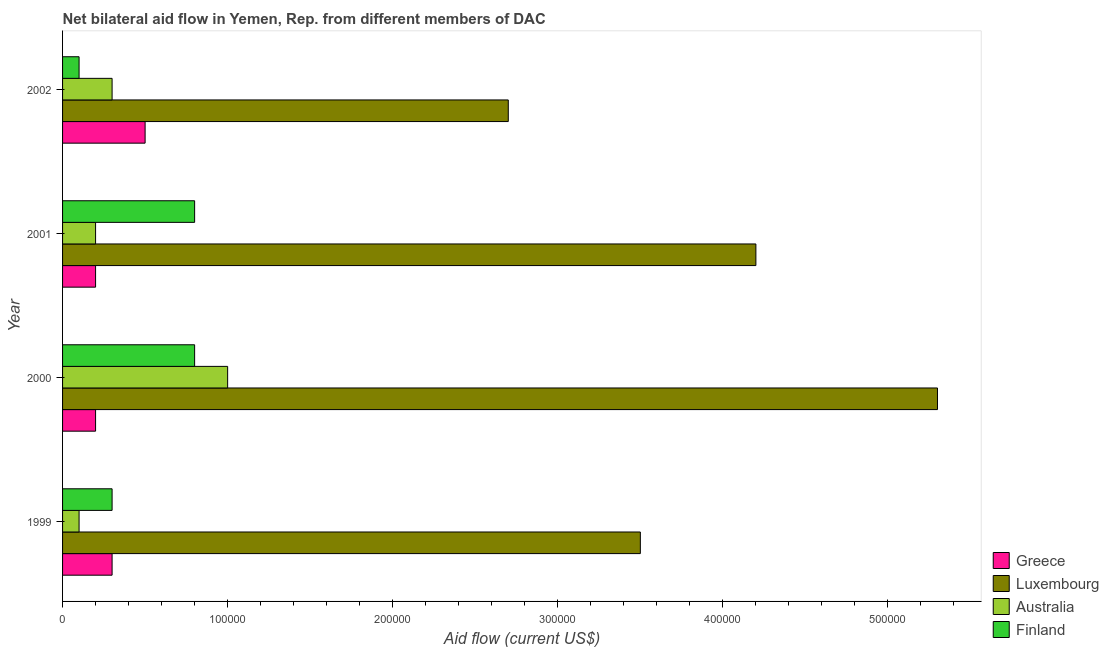How many different coloured bars are there?
Your answer should be very brief. 4. How many groups of bars are there?
Provide a short and direct response. 4. Are the number of bars per tick equal to the number of legend labels?
Provide a short and direct response. Yes. What is the amount of aid given by luxembourg in 2001?
Offer a terse response. 4.20e+05. Across all years, what is the maximum amount of aid given by luxembourg?
Provide a short and direct response. 5.30e+05. Across all years, what is the minimum amount of aid given by luxembourg?
Keep it short and to the point. 2.70e+05. In which year was the amount of aid given by finland maximum?
Offer a terse response. 2000. In which year was the amount of aid given by australia minimum?
Give a very brief answer. 1999. What is the total amount of aid given by luxembourg in the graph?
Give a very brief answer. 1.57e+06. What is the difference between the amount of aid given by greece in 1999 and that in 2001?
Keep it short and to the point. 10000. What is the difference between the amount of aid given by finland in 2000 and the amount of aid given by australia in 1999?
Give a very brief answer. 7.00e+04. What is the average amount of aid given by australia per year?
Provide a succinct answer. 4.00e+04. In the year 2001, what is the difference between the amount of aid given by australia and amount of aid given by greece?
Make the answer very short. 0. What is the ratio of the amount of aid given by luxembourg in 1999 to that in 2000?
Give a very brief answer. 0.66. What is the difference between the highest and the lowest amount of aid given by greece?
Ensure brevity in your answer.  3.00e+04. Is the sum of the amount of aid given by australia in 2000 and 2001 greater than the maximum amount of aid given by finland across all years?
Give a very brief answer. Yes. Is it the case that in every year, the sum of the amount of aid given by luxembourg and amount of aid given by australia is greater than the sum of amount of aid given by finland and amount of aid given by greece?
Provide a succinct answer. Yes. What does the 4th bar from the bottom in 2002 represents?
Provide a short and direct response. Finland. What is the difference between two consecutive major ticks on the X-axis?
Ensure brevity in your answer.  1.00e+05. Are the values on the major ticks of X-axis written in scientific E-notation?
Your answer should be compact. No. Where does the legend appear in the graph?
Offer a very short reply. Bottom right. How are the legend labels stacked?
Provide a short and direct response. Vertical. What is the title of the graph?
Your answer should be compact. Net bilateral aid flow in Yemen, Rep. from different members of DAC. Does "Minerals" appear as one of the legend labels in the graph?
Ensure brevity in your answer.  No. What is the label or title of the X-axis?
Make the answer very short. Aid flow (current US$). What is the Aid flow (current US$) of Greece in 1999?
Make the answer very short. 3.00e+04. What is the Aid flow (current US$) of Luxembourg in 1999?
Your response must be concise. 3.50e+05. What is the Aid flow (current US$) in Finland in 1999?
Provide a short and direct response. 3.00e+04. What is the Aid flow (current US$) in Luxembourg in 2000?
Offer a very short reply. 5.30e+05. What is the Aid flow (current US$) of Finland in 2000?
Provide a short and direct response. 8.00e+04. What is the Aid flow (current US$) of Greece in 2001?
Provide a succinct answer. 2.00e+04. What is the Aid flow (current US$) in Luxembourg in 2002?
Your response must be concise. 2.70e+05. What is the Aid flow (current US$) in Australia in 2002?
Your answer should be very brief. 3.00e+04. Across all years, what is the maximum Aid flow (current US$) of Greece?
Keep it short and to the point. 5.00e+04. Across all years, what is the maximum Aid flow (current US$) in Luxembourg?
Offer a very short reply. 5.30e+05. Across all years, what is the maximum Aid flow (current US$) in Australia?
Offer a very short reply. 1.00e+05. Across all years, what is the maximum Aid flow (current US$) in Finland?
Give a very brief answer. 8.00e+04. Across all years, what is the minimum Aid flow (current US$) in Finland?
Give a very brief answer. 10000. What is the total Aid flow (current US$) of Luxembourg in the graph?
Your answer should be compact. 1.57e+06. What is the total Aid flow (current US$) in Finland in the graph?
Your answer should be very brief. 2.00e+05. What is the difference between the Aid flow (current US$) of Luxembourg in 1999 and that in 2001?
Offer a terse response. -7.00e+04. What is the difference between the Aid flow (current US$) in Luxembourg in 1999 and that in 2002?
Ensure brevity in your answer.  8.00e+04. What is the difference between the Aid flow (current US$) of Australia in 1999 and that in 2002?
Your answer should be very brief. -2.00e+04. What is the difference between the Aid flow (current US$) of Finland in 1999 and that in 2002?
Ensure brevity in your answer.  2.00e+04. What is the difference between the Aid flow (current US$) in Luxembourg in 2000 and that in 2001?
Provide a short and direct response. 1.10e+05. What is the difference between the Aid flow (current US$) of Greece in 2000 and that in 2002?
Your answer should be very brief. -3.00e+04. What is the difference between the Aid flow (current US$) of Luxembourg in 2000 and that in 2002?
Your answer should be compact. 2.60e+05. What is the difference between the Aid flow (current US$) of Australia in 2000 and that in 2002?
Your response must be concise. 7.00e+04. What is the difference between the Aid flow (current US$) in Australia in 2001 and that in 2002?
Keep it short and to the point. -10000. What is the difference between the Aid flow (current US$) of Greece in 1999 and the Aid flow (current US$) of Luxembourg in 2000?
Your answer should be very brief. -5.00e+05. What is the difference between the Aid flow (current US$) of Greece in 1999 and the Aid flow (current US$) of Australia in 2000?
Provide a short and direct response. -7.00e+04. What is the difference between the Aid flow (current US$) in Greece in 1999 and the Aid flow (current US$) in Finland in 2000?
Provide a short and direct response. -5.00e+04. What is the difference between the Aid flow (current US$) of Luxembourg in 1999 and the Aid flow (current US$) of Australia in 2000?
Keep it short and to the point. 2.50e+05. What is the difference between the Aid flow (current US$) of Luxembourg in 1999 and the Aid flow (current US$) of Finland in 2000?
Your answer should be very brief. 2.70e+05. What is the difference between the Aid flow (current US$) in Australia in 1999 and the Aid flow (current US$) in Finland in 2000?
Give a very brief answer. -7.00e+04. What is the difference between the Aid flow (current US$) in Greece in 1999 and the Aid flow (current US$) in Luxembourg in 2001?
Give a very brief answer. -3.90e+05. What is the difference between the Aid flow (current US$) of Greece in 1999 and the Aid flow (current US$) of Finland in 2001?
Provide a succinct answer. -5.00e+04. What is the difference between the Aid flow (current US$) of Luxembourg in 1999 and the Aid flow (current US$) of Australia in 2001?
Provide a short and direct response. 3.30e+05. What is the difference between the Aid flow (current US$) of Luxembourg in 1999 and the Aid flow (current US$) of Australia in 2002?
Ensure brevity in your answer.  3.20e+05. What is the difference between the Aid flow (current US$) of Luxembourg in 1999 and the Aid flow (current US$) of Finland in 2002?
Offer a terse response. 3.40e+05. What is the difference between the Aid flow (current US$) of Australia in 1999 and the Aid flow (current US$) of Finland in 2002?
Your response must be concise. 0. What is the difference between the Aid flow (current US$) in Greece in 2000 and the Aid flow (current US$) in Luxembourg in 2001?
Make the answer very short. -4.00e+05. What is the difference between the Aid flow (current US$) in Greece in 2000 and the Aid flow (current US$) in Australia in 2001?
Provide a succinct answer. 0. What is the difference between the Aid flow (current US$) of Luxembourg in 2000 and the Aid flow (current US$) of Australia in 2001?
Ensure brevity in your answer.  5.10e+05. What is the difference between the Aid flow (current US$) in Luxembourg in 2000 and the Aid flow (current US$) in Finland in 2001?
Offer a terse response. 4.50e+05. What is the difference between the Aid flow (current US$) in Luxembourg in 2000 and the Aid flow (current US$) in Australia in 2002?
Give a very brief answer. 5.00e+05. What is the difference between the Aid flow (current US$) of Luxembourg in 2000 and the Aid flow (current US$) of Finland in 2002?
Offer a very short reply. 5.20e+05. What is the difference between the Aid flow (current US$) in Greece in 2001 and the Aid flow (current US$) in Australia in 2002?
Give a very brief answer. -10000. What is the difference between the Aid flow (current US$) of Greece in 2001 and the Aid flow (current US$) of Finland in 2002?
Make the answer very short. 10000. What is the difference between the Aid flow (current US$) of Luxembourg in 2001 and the Aid flow (current US$) of Finland in 2002?
Your response must be concise. 4.10e+05. What is the difference between the Aid flow (current US$) in Australia in 2001 and the Aid flow (current US$) in Finland in 2002?
Make the answer very short. 10000. What is the average Aid flow (current US$) in Luxembourg per year?
Offer a very short reply. 3.92e+05. What is the average Aid flow (current US$) of Australia per year?
Your answer should be very brief. 4.00e+04. What is the average Aid flow (current US$) in Finland per year?
Provide a succinct answer. 5.00e+04. In the year 1999, what is the difference between the Aid flow (current US$) of Greece and Aid flow (current US$) of Luxembourg?
Offer a terse response. -3.20e+05. In the year 1999, what is the difference between the Aid flow (current US$) in Greece and Aid flow (current US$) in Australia?
Make the answer very short. 2.00e+04. In the year 1999, what is the difference between the Aid flow (current US$) in Greece and Aid flow (current US$) in Finland?
Make the answer very short. 0. In the year 1999, what is the difference between the Aid flow (current US$) in Luxembourg and Aid flow (current US$) in Australia?
Provide a short and direct response. 3.40e+05. In the year 1999, what is the difference between the Aid flow (current US$) of Luxembourg and Aid flow (current US$) of Finland?
Make the answer very short. 3.20e+05. In the year 1999, what is the difference between the Aid flow (current US$) in Australia and Aid flow (current US$) in Finland?
Offer a terse response. -2.00e+04. In the year 2000, what is the difference between the Aid flow (current US$) in Greece and Aid flow (current US$) in Luxembourg?
Offer a very short reply. -5.10e+05. In the year 2000, what is the difference between the Aid flow (current US$) in Greece and Aid flow (current US$) in Finland?
Your answer should be compact. -6.00e+04. In the year 2000, what is the difference between the Aid flow (current US$) of Luxembourg and Aid flow (current US$) of Australia?
Your answer should be compact. 4.30e+05. In the year 2001, what is the difference between the Aid flow (current US$) of Greece and Aid flow (current US$) of Luxembourg?
Your response must be concise. -4.00e+05. In the year 2001, what is the difference between the Aid flow (current US$) of Greece and Aid flow (current US$) of Australia?
Keep it short and to the point. 0. In the year 2001, what is the difference between the Aid flow (current US$) in Luxembourg and Aid flow (current US$) in Finland?
Your answer should be very brief. 3.40e+05. In the year 2002, what is the difference between the Aid flow (current US$) in Australia and Aid flow (current US$) in Finland?
Provide a short and direct response. 2.00e+04. What is the ratio of the Aid flow (current US$) of Greece in 1999 to that in 2000?
Your response must be concise. 1.5. What is the ratio of the Aid flow (current US$) in Luxembourg in 1999 to that in 2000?
Give a very brief answer. 0.66. What is the ratio of the Aid flow (current US$) of Australia in 1999 to that in 2000?
Give a very brief answer. 0.1. What is the ratio of the Aid flow (current US$) in Finland in 1999 to that in 2000?
Ensure brevity in your answer.  0.38. What is the ratio of the Aid flow (current US$) of Finland in 1999 to that in 2001?
Provide a short and direct response. 0.38. What is the ratio of the Aid flow (current US$) in Greece in 1999 to that in 2002?
Your answer should be very brief. 0.6. What is the ratio of the Aid flow (current US$) in Luxembourg in 1999 to that in 2002?
Provide a succinct answer. 1.3. What is the ratio of the Aid flow (current US$) of Australia in 1999 to that in 2002?
Give a very brief answer. 0.33. What is the ratio of the Aid flow (current US$) of Finland in 1999 to that in 2002?
Your answer should be compact. 3. What is the ratio of the Aid flow (current US$) of Luxembourg in 2000 to that in 2001?
Give a very brief answer. 1.26. What is the ratio of the Aid flow (current US$) of Greece in 2000 to that in 2002?
Offer a very short reply. 0.4. What is the ratio of the Aid flow (current US$) in Luxembourg in 2000 to that in 2002?
Your response must be concise. 1.96. What is the ratio of the Aid flow (current US$) in Finland in 2000 to that in 2002?
Your answer should be compact. 8. What is the ratio of the Aid flow (current US$) in Greece in 2001 to that in 2002?
Provide a short and direct response. 0.4. What is the ratio of the Aid flow (current US$) in Luxembourg in 2001 to that in 2002?
Provide a succinct answer. 1.56. What is the difference between the highest and the second highest Aid flow (current US$) in Luxembourg?
Offer a very short reply. 1.10e+05. What is the difference between the highest and the second highest Aid flow (current US$) of Finland?
Offer a terse response. 0. 